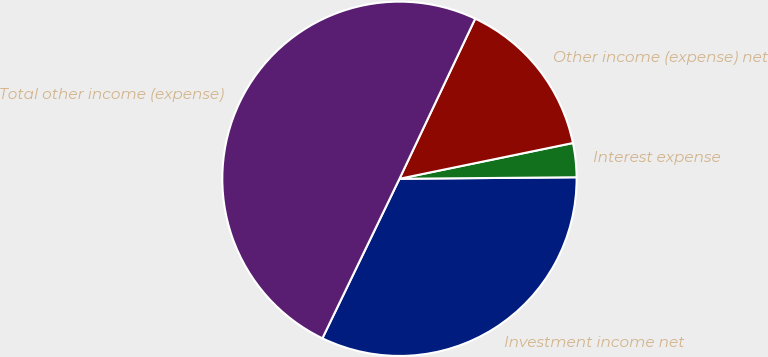Convert chart to OTSL. <chart><loc_0><loc_0><loc_500><loc_500><pie_chart><fcel>Investment income net<fcel>Interest expense<fcel>Other income (expense) net<fcel>Total other income (expense)<nl><fcel>32.3%<fcel>3.1%<fcel>14.73%<fcel>49.87%<nl></chart> 